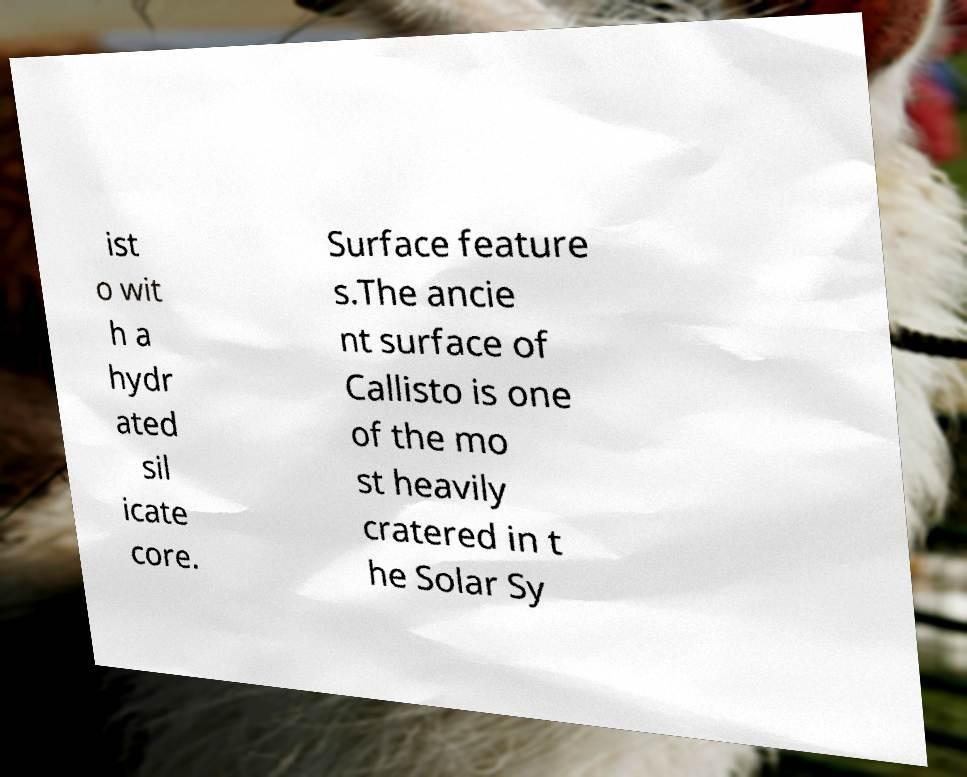There's text embedded in this image that I need extracted. Can you transcribe it verbatim? ist o wit h a hydr ated sil icate core. Surface feature s.The ancie nt surface of Callisto is one of the mo st heavily cratered in t he Solar Sy 